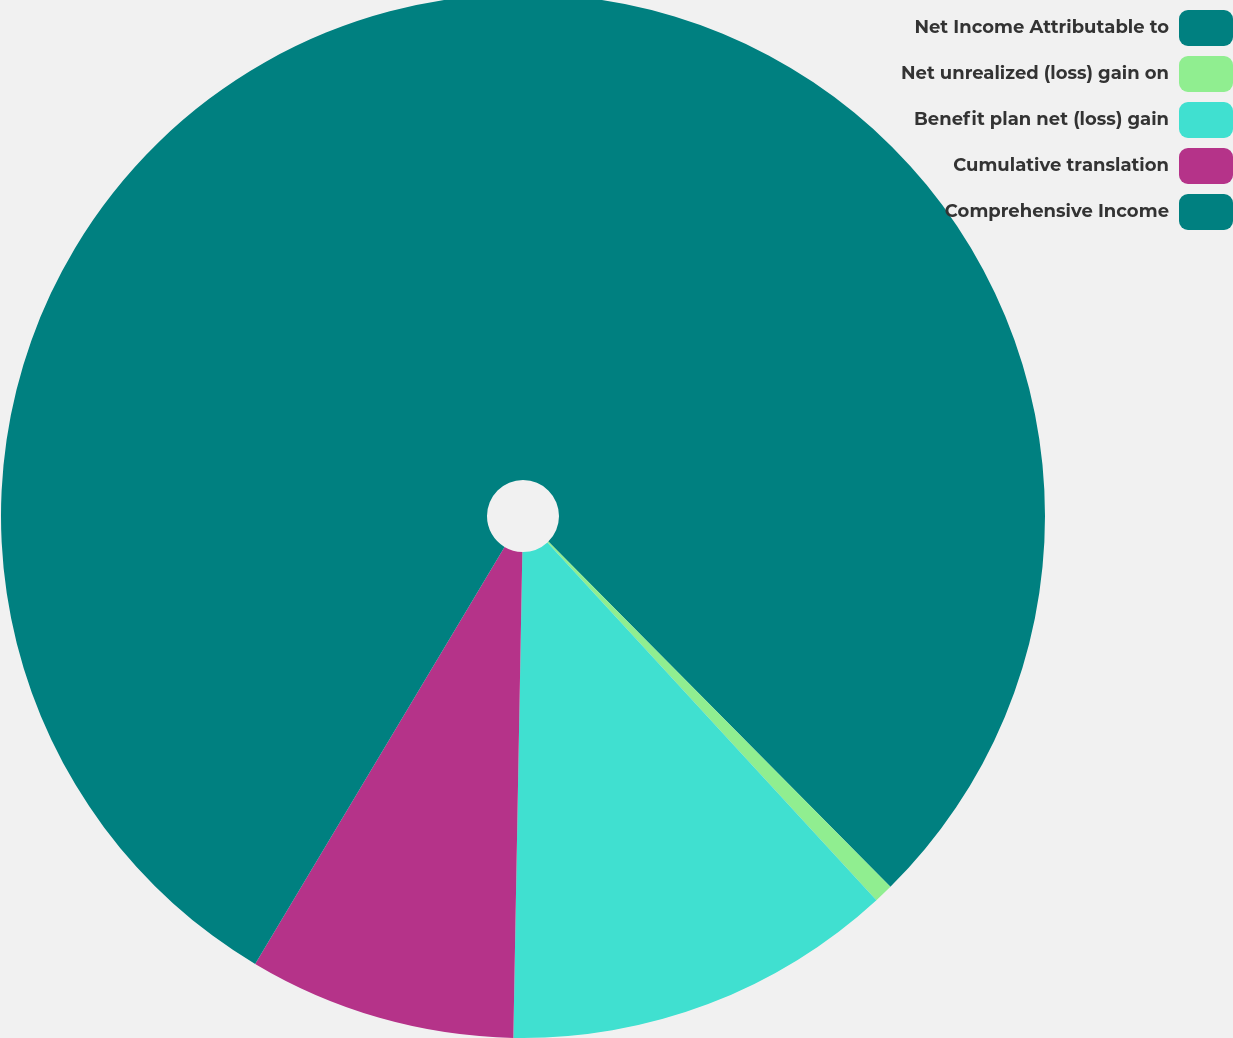<chart> <loc_0><loc_0><loc_500><loc_500><pie_chart><fcel>Net Income Attributable to<fcel>Net unrealized (loss) gain on<fcel>Benefit plan net (loss) gain<fcel>Cumulative translation<fcel>Comprehensive Income<nl><fcel>37.57%<fcel>0.59%<fcel>12.13%<fcel>8.28%<fcel>41.42%<nl></chart> 